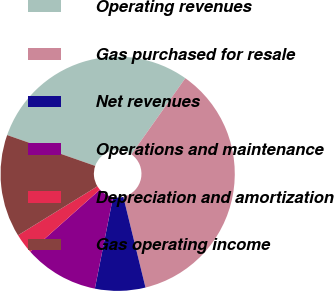<chart> <loc_0><loc_0><loc_500><loc_500><pie_chart><fcel>Operating revenues<fcel>Gas purchased for resale<fcel>Net revenues<fcel>Operations and maintenance<fcel>Depreciation and amortization<fcel>Gas operating income<nl><fcel>29.44%<fcel>36.38%<fcel>6.94%<fcel>10.3%<fcel>2.78%<fcel>14.16%<nl></chart> 